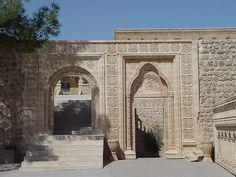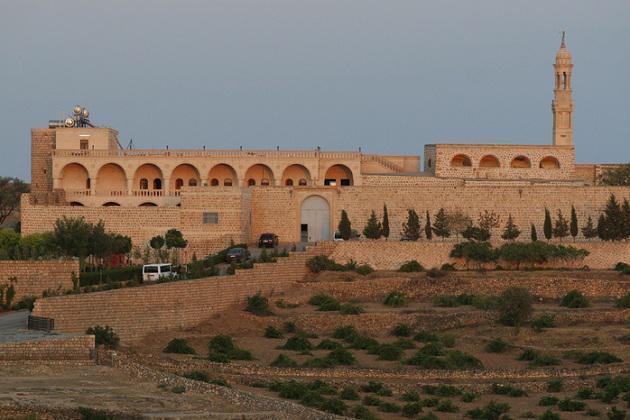The first image is the image on the left, the second image is the image on the right. Examine the images to the left and right. Is the description "A set of stairs lead to an arch in at least one image." accurate? Answer yes or no. Yes. 